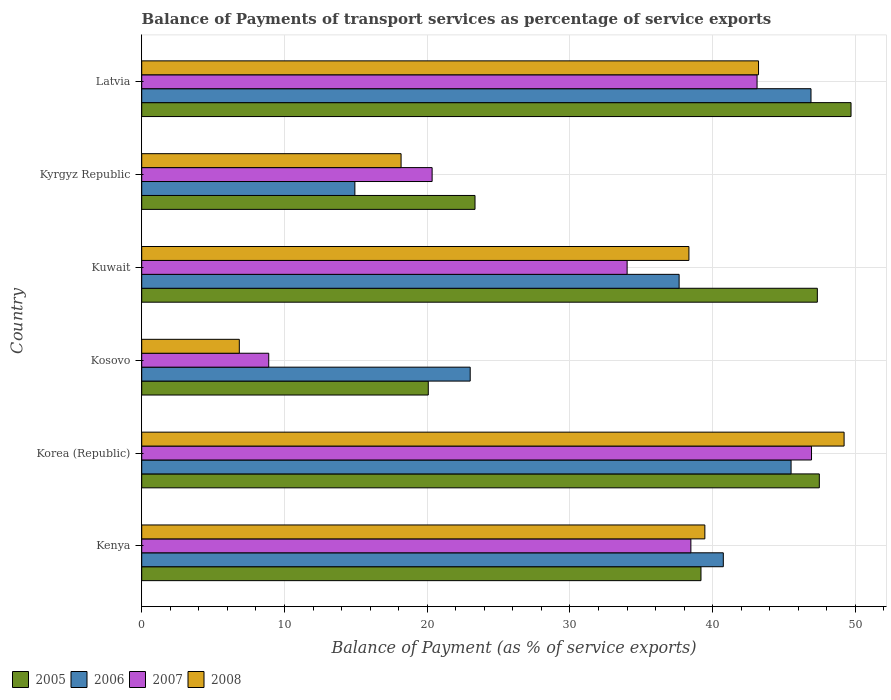How many groups of bars are there?
Make the answer very short. 6. Are the number of bars per tick equal to the number of legend labels?
Make the answer very short. Yes. Are the number of bars on each tick of the Y-axis equal?
Your answer should be compact. Yes. What is the label of the 4th group of bars from the top?
Ensure brevity in your answer.  Kosovo. In how many cases, is the number of bars for a given country not equal to the number of legend labels?
Provide a succinct answer. 0. What is the balance of payments of transport services in 2005 in Korea (Republic)?
Ensure brevity in your answer.  47.47. Across all countries, what is the maximum balance of payments of transport services in 2005?
Ensure brevity in your answer.  49.69. Across all countries, what is the minimum balance of payments of transport services in 2005?
Offer a very short reply. 20.08. In which country was the balance of payments of transport services in 2005 minimum?
Offer a very short reply. Kosovo. What is the total balance of payments of transport services in 2005 in the graph?
Ensure brevity in your answer.  227.1. What is the difference between the balance of payments of transport services in 2005 in Korea (Republic) and that in Latvia?
Provide a succinct answer. -2.22. What is the difference between the balance of payments of transport services in 2008 in Kosovo and the balance of payments of transport services in 2007 in Kyrgyz Republic?
Provide a succinct answer. -13.51. What is the average balance of payments of transport services in 2006 per country?
Give a very brief answer. 34.79. What is the difference between the balance of payments of transport services in 2006 and balance of payments of transport services in 2005 in Kenya?
Keep it short and to the point. 1.56. In how many countries, is the balance of payments of transport services in 2008 greater than 10 %?
Offer a very short reply. 5. What is the ratio of the balance of payments of transport services in 2006 in Kyrgyz Republic to that in Latvia?
Ensure brevity in your answer.  0.32. Is the difference between the balance of payments of transport services in 2006 in Kuwait and Kyrgyz Republic greater than the difference between the balance of payments of transport services in 2005 in Kuwait and Kyrgyz Republic?
Your answer should be compact. No. What is the difference between the highest and the second highest balance of payments of transport services in 2006?
Your response must be concise. 1.4. What is the difference between the highest and the lowest balance of payments of transport services in 2007?
Make the answer very short. 38.03. Is the sum of the balance of payments of transport services in 2006 in Kosovo and Kyrgyz Republic greater than the maximum balance of payments of transport services in 2005 across all countries?
Your answer should be very brief. No. What does the 1st bar from the bottom in Korea (Republic) represents?
Provide a short and direct response. 2005. Is it the case that in every country, the sum of the balance of payments of transport services in 2007 and balance of payments of transport services in 2005 is greater than the balance of payments of transport services in 2008?
Provide a succinct answer. Yes. How many bars are there?
Make the answer very short. 24. Are all the bars in the graph horizontal?
Your answer should be compact. Yes. Are the values on the major ticks of X-axis written in scientific E-notation?
Your answer should be compact. No. How are the legend labels stacked?
Offer a very short reply. Horizontal. What is the title of the graph?
Offer a very short reply. Balance of Payments of transport services as percentage of service exports. Does "1960" appear as one of the legend labels in the graph?
Keep it short and to the point. No. What is the label or title of the X-axis?
Offer a very short reply. Balance of Payment (as % of service exports). What is the Balance of Payment (as % of service exports) in 2005 in Kenya?
Provide a short and direct response. 39.18. What is the Balance of Payment (as % of service exports) of 2006 in Kenya?
Provide a short and direct response. 40.74. What is the Balance of Payment (as % of service exports) in 2007 in Kenya?
Provide a short and direct response. 38.47. What is the Balance of Payment (as % of service exports) of 2008 in Kenya?
Your answer should be very brief. 39.45. What is the Balance of Payment (as % of service exports) of 2005 in Korea (Republic)?
Keep it short and to the point. 47.47. What is the Balance of Payment (as % of service exports) in 2006 in Korea (Republic)?
Ensure brevity in your answer.  45.49. What is the Balance of Payment (as % of service exports) in 2007 in Korea (Republic)?
Provide a succinct answer. 46.92. What is the Balance of Payment (as % of service exports) in 2008 in Korea (Republic)?
Your response must be concise. 49.21. What is the Balance of Payment (as % of service exports) of 2005 in Kosovo?
Make the answer very short. 20.08. What is the Balance of Payment (as % of service exports) in 2006 in Kosovo?
Give a very brief answer. 23.01. What is the Balance of Payment (as % of service exports) in 2007 in Kosovo?
Offer a very short reply. 8.9. What is the Balance of Payment (as % of service exports) in 2008 in Kosovo?
Provide a succinct answer. 6.84. What is the Balance of Payment (as % of service exports) in 2005 in Kuwait?
Offer a very short reply. 47.33. What is the Balance of Payment (as % of service exports) in 2006 in Kuwait?
Your response must be concise. 37.65. What is the Balance of Payment (as % of service exports) of 2007 in Kuwait?
Your response must be concise. 34.01. What is the Balance of Payment (as % of service exports) of 2008 in Kuwait?
Provide a short and direct response. 38.33. What is the Balance of Payment (as % of service exports) in 2005 in Kyrgyz Republic?
Your answer should be compact. 23.35. What is the Balance of Payment (as % of service exports) of 2006 in Kyrgyz Republic?
Offer a very short reply. 14.93. What is the Balance of Payment (as % of service exports) of 2007 in Kyrgyz Republic?
Your response must be concise. 20.34. What is the Balance of Payment (as % of service exports) in 2008 in Kyrgyz Republic?
Offer a very short reply. 18.17. What is the Balance of Payment (as % of service exports) of 2005 in Latvia?
Your response must be concise. 49.69. What is the Balance of Payment (as % of service exports) of 2006 in Latvia?
Provide a succinct answer. 46.89. What is the Balance of Payment (as % of service exports) in 2007 in Latvia?
Offer a very short reply. 43.11. What is the Balance of Payment (as % of service exports) in 2008 in Latvia?
Your answer should be compact. 43.21. Across all countries, what is the maximum Balance of Payment (as % of service exports) of 2005?
Keep it short and to the point. 49.69. Across all countries, what is the maximum Balance of Payment (as % of service exports) of 2006?
Make the answer very short. 46.89. Across all countries, what is the maximum Balance of Payment (as % of service exports) of 2007?
Your answer should be compact. 46.92. Across all countries, what is the maximum Balance of Payment (as % of service exports) of 2008?
Your answer should be compact. 49.21. Across all countries, what is the minimum Balance of Payment (as % of service exports) in 2005?
Your answer should be compact. 20.08. Across all countries, what is the minimum Balance of Payment (as % of service exports) of 2006?
Your answer should be very brief. 14.93. Across all countries, what is the minimum Balance of Payment (as % of service exports) of 2007?
Give a very brief answer. 8.9. Across all countries, what is the minimum Balance of Payment (as % of service exports) of 2008?
Give a very brief answer. 6.84. What is the total Balance of Payment (as % of service exports) in 2005 in the graph?
Offer a very short reply. 227.1. What is the total Balance of Payment (as % of service exports) of 2006 in the graph?
Offer a terse response. 208.72. What is the total Balance of Payment (as % of service exports) of 2007 in the graph?
Ensure brevity in your answer.  191.75. What is the total Balance of Payment (as % of service exports) in 2008 in the graph?
Offer a terse response. 195.21. What is the difference between the Balance of Payment (as % of service exports) in 2005 in Kenya and that in Korea (Republic)?
Your response must be concise. -8.29. What is the difference between the Balance of Payment (as % of service exports) in 2006 in Kenya and that in Korea (Republic)?
Provide a short and direct response. -4.75. What is the difference between the Balance of Payment (as % of service exports) in 2007 in Kenya and that in Korea (Republic)?
Provide a short and direct response. -8.45. What is the difference between the Balance of Payment (as % of service exports) in 2008 in Kenya and that in Korea (Republic)?
Ensure brevity in your answer.  -9.75. What is the difference between the Balance of Payment (as % of service exports) in 2005 in Kenya and that in Kosovo?
Offer a very short reply. 19.1. What is the difference between the Balance of Payment (as % of service exports) of 2006 in Kenya and that in Kosovo?
Your answer should be very brief. 17.73. What is the difference between the Balance of Payment (as % of service exports) of 2007 in Kenya and that in Kosovo?
Offer a very short reply. 29.57. What is the difference between the Balance of Payment (as % of service exports) of 2008 in Kenya and that in Kosovo?
Give a very brief answer. 32.62. What is the difference between the Balance of Payment (as % of service exports) of 2005 in Kenya and that in Kuwait?
Give a very brief answer. -8.15. What is the difference between the Balance of Payment (as % of service exports) of 2006 in Kenya and that in Kuwait?
Your response must be concise. 3.1. What is the difference between the Balance of Payment (as % of service exports) in 2007 in Kenya and that in Kuwait?
Offer a terse response. 4.47. What is the difference between the Balance of Payment (as % of service exports) of 2008 in Kenya and that in Kuwait?
Keep it short and to the point. 1.12. What is the difference between the Balance of Payment (as % of service exports) of 2005 in Kenya and that in Kyrgyz Republic?
Ensure brevity in your answer.  15.83. What is the difference between the Balance of Payment (as % of service exports) in 2006 in Kenya and that in Kyrgyz Republic?
Ensure brevity in your answer.  25.81. What is the difference between the Balance of Payment (as % of service exports) in 2007 in Kenya and that in Kyrgyz Republic?
Provide a succinct answer. 18.13. What is the difference between the Balance of Payment (as % of service exports) of 2008 in Kenya and that in Kyrgyz Republic?
Provide a succinct answer. 21.28. What is the difference between the Balance of Payment (as % of service exports) in 2005 in Kenya and that in Latvia?
Ensure brevity in your answer.  -10.51. What is the difference between the Balance of Payment (as % of service exports) in 2006 in Kenya and that in Latvia?
Ensure brevity in your answer.  -6.14. What is the difference between the Balance of Payment (as % of service exports) in 2007 in Kenya and that in Latvia?
Your answer should be compact. -4.64. What is the difference between the Balance of Payment (as % of service exports) in 2008 in Kenya and that in Latvia?
Your answer should be very brief. -3.76. What is the difference between the Balance of Payment (as % of service exports) in 2005 in Korea (Republic) and that in Kosovo?
Your response must be concise. 27.4. What is the difference between the Balance of Payment (as % of service exports) in 2006 in Korea (Republic) and that in Kosovo?
Provide a succinct answer. 22.48. What is the difference between the Balance of Payment (as % of service exports) of 2007 in Korea (Republic) and that in Kosovo?
Provide a succinct answer. 38.03. What is the difference between the Balance of Payment (as % of service exports) of 2008 in Korea (Republic) and that in Kosovo?
Offer a very short reply. 42.37. What is the difference between the Balance of Payment (as % of service exports) in 2005 in Korea (Republic) and that in Kuwait?
Ensure brevity in your answer.  0.14. What is the difference between the Balance of Payment (as % of service exports) of 2006 in Korea (Republic) and that in Kuwait?
Your answer should be very brief. 7.84. What is the difference between the Balance of Payment (as % of service exports) of 2007 in Korea (Republic) and that in Kuwait?
Give a very brief answer. 12.92. What is the difference between the Balance of Payment (as % of service exports) of 2008 in Korea (Republic) and that in Kuwait?
Ensure brevity in your answer.  10.87. What is the difference between the Balance of Payment (as % of service exports) in 2005 in Korea (Republic) and that in Kyrgyz Republic?
Your response must be concise. 24.12. What is the difference between the Balance of Payment (as % of service exports) in 2006 in Korea (Republic) and that in Kyrgyz Republic?
Keep it short and to the point. 30.56. What is the difference between the Balance of Payment (as % of service exports) in 2007 in Korea (Republic) and that in Kyrgyz Republic?
Your answer should be very brief. 26.58. What is the difference between the Balance of Payment (as % of service exports) in 2008 in Korea (Republic) and that in Kyrgyz Republic?
Your answer should be compact. 31.04. What is the difference between the Balance of Payment (as % of service exports) in 2005 in Korea (Republic) and that in Latvia?
Keep it short and to the point. -2.22. What is the difference between the Balance of Payment (as % of service exports) of 2006 in Korea (Republic) and that in Latvia?
Offer a very short reply. -1.4. What is the difference between the Balance of Payment (as % of service exports) of 2007 in Korea (Republic) and that in Latvia?
Give a very brief answer. 3.82. What is the difference between the Balance of Payment (as % of service exports) of 2008 in Korea (Republic) and that in Latvia?
Keep it short and to the point. 5.99. What is the difference between the Balance of Payment (as % of service exports) of 2005 in Kosovo and that in Kuwait?
Offer a terse response. -27.26. What is the difference between the Balance of Payment (as % of service exports) in 2006 in Kosovo and that in Kuwait?
Keep it short and to the point. -14.64. What is the difference between the Balance of Payment (as % of service exports) of 2007 in Kosovo and that in Kuwait?
Keep it short and to the point. -25.11. What is the difference between the Balance of Payment (as % of service exports) in 2008 in Kosovo and that in Kuwait?
Ensure brevity in your answer.  -31.5. What is the difference between the Balance of Payment (as % of service exports) of 2005 in Kosovo and that in Kyrgyz Republic?
Give a very brief answer. -3.27. What is the difference between the Balance of Payment (as % of service exports) in 2006 in Kosovo and that in Kyrgyz Republic?
Provide a short and direct response. 8.08. What is the difference between the Balance of Payment (as % of service exports) of 2007 in Kosovo and that in Kyrgyz Republic?
Offer a terse response. -11.45. What is the difference between the Balance of Payment (as % of service exports) of 2008 in Kosovo and that in Kyrgyz Republic?
Your answer should be very brief. -11.33. What is the difference between the Balance of Payment (as % of service exports) of 2005 in Kosovo and that in Latvia?
Make the answer very short. -29.62. What is the difference between the Balance of Payment (as % of service exports) of 2006 in Kosovo and that in Latvia?
Your answer should be very brief. -23.87. What is the difference between the Balance of Payment (as % of service exports) of 2007 in Kosovo and that in Latvia?
Keep it short and to the point. -34.21. What is the difference between the Balance of Payment (as % of service exports) of 2008 in Kosovo and that in Latvia?
Provide a succinct answer. -36.38. What is the difference between the Balance of Payment (as % of service exports) of 2005 in Kuwait and that in Kyrgyz Republic?
Offer a terse response. 23.98. What is the difference between the Balance of Payment (as % of service exports) in 2006 in Kuwait and that in Kyrgyz Republic?
Keep it short and to the point. 22.72. What is the difference between the Balance of Payment (as % of service exports) of 2007 in Kuwait and that in Kyrgyz Republic?
Your response must be concise. 13.66. What is the difference between the Balance of Payment (as % of service exports) of 2008 in Kuwait and that in Kyrgyz Republic?
Provide a short and direct response. 20.17. What is the difference between the Balance of Payment (as % of service exports) of 2005 in Kuwait and that in Latvia?
Offer a terse response. -2.36. What is the difference between the Balance of Payment (as % of service exports) of 2006 in Kuwait and that in Latvia?
Keep it short and to the point. -9.24. What is the difference between the Balance of Payment (as % of service exports) of 2007 in Kuwait and that in Latvia?
Your response must be concise. -9.1. What is the difference between the Balance of Payment (as % of service exports) of 2008 in Kuwait and that in Latvia?
Your answer should be compact. -4.88. What is the difference between the Balance of Payment (as % of service exports) of 2005 in Kyrgyz Republic and that in Latvia?
Provide a succinct answer. -26.34. What is the difference between the Balance of Payment (as % of service exports) of 2006 in Kyrgyz Republic and that in Latvia?
Keep it short and to the point. -31.95. What is the difference between the Balance of Payment (as % of service exports) of 2007 in Kyrgyz Republic and that in Latvia?
Your answer should be very brief. -22.76. What is the difference between the Balance of Payment (as % of service exports) of 2008 in Kyrgyz Republic and that in Latvia?
Make the answer very short. -25.04. What is the difference between the Balance of Payment (as % of service exports) in 2005 in Kenya and the Balance of Payment (as % of service exports) in 2006 in Korea (Republic)?
Your answer should be compact. -6.31. What is the difference between the Balance of Payment (as % of service exports) of 2005 in Kenya and the Balance of Payment (as % of service exports) of 2007 in Korea (Republic)?
Your response must be concise. -7.74. What is the difference between the Balance of Payment (as % of service exports) of 2005 in Kenya and the Balance of Payment (as % of service exports) of 2008 in Korea (Republic)?
Keep it short and to the point. -10.03. What is the difference between the Balance of Payment (as % of service exports) in 2006 in Kenya and the Balance of Payment (as % of service exports) in 2007 in Korea (Republic)?
Your answer should be compact. -6.18. What is the difference between the Balance of Payment (as % of service exports) of 2006 in Kenya and the Balance of Payment (as % of service exports) of 2008 in Korea (Republic)?
Your answer should be very brief. -8.46. What is the difference between the Balance of Payment (as % of service exports) of 2007 in Kenya and the Balance of Payment (as % of service exports) of 2008 in Korea (Republic)?
Your response must be concise. -10.73. What is the difference between the Balance of Payment (as % of service exports) of 2005 in Kenya and the Balance of Payment (as % of service exports) of 2006 in Kosovo?
Ensure brevity in your answer.  16.17. What is the difference between the Balance of Payment (as % of service exports) in 2005 in Kenya and the Balance of Payment (as % of service exports) in 2007 in Kosovo?
Provide a short and direct response. 30.28. What is the difference between the Balance of Payment (as % of service exports) in 2005 in Kenya and the Balance of Payment (as % of service exports) in 2008 in Kosovo?
Offer a very short reply. 32.34. What is the difference between the Balance of Payment (as % of service exports) in 2006 in Kenya and the Balance of Payment (as % of service exports) in 2007 in Kosovo?
Your answer should be compact. 31.85. What is the difference between the Balance of Payment (as % of service exports) in 2006 in Kenya and the Balance of Payment (as % of service exports) in 2008 in Kosovo?
Your response must be concise. 33.91. What is the difference between the Balance of Payment (as % of service exports) in 2007 in Kenya and the Balance of Payment (as % of service exports) in 2008 in Kosovo?
Give a very brief answer. 31.63. What is the difference between the Balance of Payment (as % of service exports) of 2005 in Kenya and the Balance of Payment (as % of service exports) of 2006 in Kuwait?
Your answer should be compact. 1.53. What is the difference between the Balance of Payment (as % of service exports) in 2005 in Kenya and the Balance of Payment (as % of service exports) in 2007 in Kuwait?
Your response must be concise. 5.17. What is the difference between the Balance of Payment (as % of service exports) in 2005 in Kenya and the Balance of Payment (as % of service exports) in 2008 in Kuwait?
Provide a short and direct response. 0.84. What is the difference between the Balance of Payment (as % of service exports) of 2006 in Kenya and the Balance of Payment (as % of service exports) of 2007 in Kuwait?
Offer a very short reply. 6.74. What is the difference between the Balance of Payment (as % of service exports) in 2006 in Kenya and the Balance of Payment (as % of service exports) in 2008 in Kuwait?
Keep it short and to the point. 2.41. What is the difference between the Balance of Payment (as % of service exports) of 2007 in Kenya and the Balance of Payment (as % of service exports) of 2008 in Kuwait?
Your answer should be very brief. 0.14. What is the difference between the Balance of Payment (as % of service exports) of 2005 in Kenya and the Balance of Payment (as % of service exports) of 2006 in Kyrgyz Republic?
Provide a succinct answer. 24.25. What is the difference between the Balance of Payment (as % of service exports) of 2005 in Kenya and the Balance of Payment (as % of service exports) of 2007 in Kyrgyz Republic?
Give a very brief answer. 18.84. What is the difference between the Balance of Payment (as % of service exports) in 2005 in Kenya and the Balance of Payment (as % of service exports) in 2008 in Kyrgyz Republic?
Offer a terse response. 21.01. What is the difference between the Balance of Payment (as % of service exports) of 2006 in Kenya and the Balance of Payment (as % of service exports) of 2007 in Kyrgyz Republic?
Make the answer very short. 20.4. What is the difference between the Balance of Payment (as % of service exports) in 2006 in Kenya and the Balance of Payment (as % of service exports) in 2008 in Kyrgyz Republic?
Provide a succinct answer. 22.58. What is the difference between the Balance of Payment (as % of service exports) in 2007 in Kenya and the Balance of Payment (as % of service exports) in 2008 in Kyrgyz Republic?
Your answer should be very brief. 20.3. What is the difference between the Balance of Payment (as % of service exports) in 2005 in Kenya and the Balance of Payment (as % of service exports) in 2006 in Latvia?
Your answer should be compact. -7.71. What is the difference between the Balance of Payment (as % of service exports) of 2005 in Kenya and the Balance of Payment (as % of service exports) of 2007 in Latvia?
Offer a terse response. -3.93. What is the difference between the Balance of Payment (as % of service exports) of 2005 in Kenya and the Balance of Payment (as % of service exports) of 2008 in Latvia?
Your answer should be very brief. -4.03. What is the difference between the Balance of Payment (as % of service exports) of 2006 in Kenya and the Balance of Payment (as % of service exports) of 2007 in Latvia?
Provide a short and direct response. -2.36. What is the difference between the Balance of Payment (as % of service exports) of 2006 in Kenya and the Balance of Payment (as % of service exports) of 2008 in Latvia?
Offer a very short reply. -2.47. What is the difference between the Balance of Payment (as % of service exports) in 2007 in Kenya and the Balance of Payment (as % of service exports) in 2008 in Latvia?
Provide a short and direct response. -4.74. What is the difference between the Balance of Payment (as % of service exports) of 2005 in Korea (Republic) and the Balance of Payment (as % of service exports) of 2006 in Kosovo?
Provide a succinct answer. 24.46. What is the difference between the Balance of Payment (as % of service exports) in 2005 in Korea (Republic) and the Balance of Payment (as % of service exports) in 2007 in Kosovo?
Your answer should be compact. 38.57. What is the difference between the Balance of Payment (as % of service exports) in 2005 in Korea (Republic) and the Balance of Payment (as % of service exports) in 2008 in Kosovo?
Your answer should be compact. 40.63. What is the difference between the Balance of Payment (as % of service exports) of 2006 in Korea (Republic) and the Balance of Payment (as % of service exports) of 2007 in Kosovo?
Offer a terse response. 36.59. What is the difference between the Balance of Payment (as % of service exports) of 2006 in Korea (Republic) and the Balance of Payment (as % of service exports) of 2008 in Kosovo?
Your response must be concise. 38.65. What is the difference between the Balance of Payment (as % of service exports) in 2007 in Korea (Republic) and the Balance of Payment (as % of service exports) in 2008 in Kosovo?
Ensure brevity in your answer.  40.09. What is the difference between the Balance of Payment (as % of service exports) in 2005 in Korea (Republic) and the Balance of Payment (as % of service exports) in 2006 in Kuwait?
Offer a terse response. 9.82. What is the difference between the Balance of Payment (as % of service exports) in 2005 in Korea (Republic) and the Balance of Payment (as % of service exports) in 2007 in Kuwait?
Ensure brevity in your answer.  13.47. What is the difference between the Balance of Payment (as % of service exports) in 2005 in Korea (Republic) and the Balance of Payment (as % of service exports) in 2008 in Kuwait?
Keep it short and to the point. 9.14. What is the difference between the Balance of Payment (as % of service exports) in 2006 in Korea (Republic) and the Balance of Payment (as % of service exports) in 2007 in Kuwait?
Your answer should be compact. 11.49. What is the difference between the Balance of Payment (as % of service exports) of 2006 in Korea (Republic) and the Balance of Payment (as % of service exports) of 2008 in Kuwait?
Provide a succinct answer. 7.16. What is the difference between the Balance of Payment (as % of service exports) in 2007 in Korea (Republic) and the Balance of Payment (as % of service exports) in 2008 in Kuwait?
Provide a succinct answer. 8.59. What is the difference between the Balance of Payment (as % of service exports) in 2005 in Korea (Republic) and the Balance of Payment (as % of service exports) in 2006 in Kyrgyz Republic?
Ensure brevity in your answer.  32.54. What is the difference between the Balance of Payment (as % of service exports) in 2005 in Korea (Republic) and the Balance of Payment (as % of service exports) in 2007 in Kyrgyz Republic?
Make the answer very short. 27.13. What is the difference between the Balance of Payment (as % of service exports) in 2005 in Korea (Republic) and the Balance of Payment (as % of service exports) in 2008 in Kyrgyz Republic?
Your response must be concise. 29.3. What is the difference between the Balance of Payment (as % of service exports) in 2006 in Korea (Republic) and the Balance of Payment (as % of service exports) in 2007 in Kyrgyz Republic?
Your response must be concise. 25.15. What is the difference between the Balance of Payment (as % of service exports) of 2006 in Korea (Republic) and the Balance of Payment (as % of service exports) of 2008 in Kyrgyz Republic?
Your answer should be compact. 27.32. What is the difference between the Balance of Payment (as % of service exports) in 2007 in Korea (Republic) and the Balance of Payment (as % of service exports) in 2008 in Kyrgyz Republic?
Your answer should be very brief. 28.75. What is the difference between the Balance of Payment (as % of service exports) in 2005 in Korea (Republic) and the Balance of Payment (as % of service exports) in 2006 in Latvia?
Offer a terse response. 0.58. What is the difference between the Balance of Payment (as % of service exports) of 2005 in Korea (Republic) and the Balance of Payment (as % of service exports) of 2007 in Latvia?
Offer a very short reply. 4.36. What is the difference between the Balance of Payment (as % of service exports) of 2005 in Korea (Republic) and the Balance of Payment (as % of service exports) of 2008 in Latvia?
Your answer should be very brief. 4.26. What is the difference between the Balance of Payment (as % of service exports) in 2006 in Korea (Republic) and the Balance of Payment (as % of service exports) in 2007 in Latvia?
Make the answer very short. 2.38. What is the difference between the Balance of Payment (as % of service exports) of 2006 in Korea (Republic) and the Balance of Payment (as % of service exports) of 2008 in Latvia?
Make the answer very short. 2.28. What is the difference between the Balance of Payment (as % of service exports) of 2007 in Korea (Republic) and the Balance of Payment (as % of service exports) of 2008 in Latvia?
Make the answer very short. 3.71. What is the difference between the Balance of Payment (as % of service exports) in 2005 in Kosovo and the Balance of Payment (as % of service exports) in 2006 in Kuwait?
Your answer should be very brief. -17.57. What is the difference between the Balance of Payment (as % of service exports) of 2005 in Kosovo and the Balance of Payment (as % of service exports) of 2007 in Kuwait?
Make the answer very short. -13.93. What is the difference between the Balance of Payment (as % of service exports) of 2005 in Kosovo and the Balance of Payment (as % of service exports) of 2008 in Kuwait?
Give a very brief answer. -18.26. What is the difference between the Balance of Payment (as % of service exports) of 2006 in Kosovo and the Balance of Payment (as % of service exports) of 2007 in Kuwait?
Offer a very short reply. -10.99. What is the difference between the Balance of Payment (as % of service exports) of 2006 in Kosovo and the Balance of Payment (as % of service exports) of 2008 in Kuwait?
Your answer should be compact. -15.32. What is the difference between the Balance of Payment (as % of service exports) of 2007 in Kosovo and the Balance of Payment (as % of service exports) of 2008 in Kuwait?
Provide a short and direct response. -29.44. What is the difference between the Balance of Payment (as % of service exports) in 2005 in Kosovo and the Balance of Payment (as % of service exports) in 2006 in Kyrgyz Republic?
Ensure brevity in your answer.  5.14. What is the difference between the Balance of Payment (as % of service exports) in 2005 in Kosovo and the Balance of Payment (as % of service exports) in 2007 in Kyrgyz Republic?
Offer a very short reply. -0.27. What is the difference between the Balance of Payment (as % of service exports) of 2005 in Kosovo and the Balance of Payment (as % of service exports) of 2008 in Kyrgyz Republic?
Your answer should be compact. 1.91. What is the difference between the Balance of Payment (as % of service exports) in 2006 in Kosovo and the Balance of Payment (as % of service exports) in 2007 in Kyrgyz Republic?
Make the answer very short. 2.67. What is the difference between the Balance of Payment (as % of service exports) in 2006 in Kosovo and the Balance of Payment (as % of service exports) in 2008 in Kyrgyz Republic?
Ensure brevity in your answer.  4.84. What is the difference between the Balance of Payment (as % of service exports) of 2007 in Kosovo and the Balance of Payment (as % of service exports) of 2008 in Kyrgyz Republic?
Your answer should be compact. -9.27. What is the difference between the Balance of Payment (as % of service exports) of 2005 in Kosovo and the Balance of Payment (as % of service exports) of 2006 in Latvia?
Keep it short and to the point. -26.81. What is the difference between the Balance of Payment (as % of service exports) in 2005 in Kosovo and the Balance of Payment (as % of service exports) in 2007 in Latvia?
Offer a terse response. -23.03. What is the difference between the Balance of Payment (as % of service exports) in 2005 in Kosovo and the Balance of Payment (as % of service exports) in 2008 in Latvia?
Keep it short and to the point. -23.14. What is the difference between the Balance of Payment (as % of service exports) of 2006 in Kosovo and the Balance of Payment (as % of service exports) of 2007 in Latvia?
Offer a terse response. -20.1. What is the difference between the Balance of Payment (as % of service exports) in 2006 in Kosovo and the Balance of Payment (as % of service exports) in 2008 in Latvia?
Offer a terse response. -20.2. What is the difference between the Balance of Payment (as % of service exports) in 2007 in Kosovo and the Balance of Payment (as % of service exports) in 2008 in Latvia?
Ensure brevity in your answer.  -34.31. What is the difference between the Balance of Payment (as % of service exports) of 2005 in Kuwait and the Balance of Payment (as % of service exports) of 2006 in Kyrgyz Republic?
Give a very brief answer. 32.4. What is the difference between the Balance of Payment (as % of service exports) of 2005 in Kuwait and the Balance of Payment (as % of service exports) of 2007 in Kyrgyz Republic?
Ensure brevity in your answer.  26.99. What is the difference between the Balance of Payment (as % of service exports) in 2005 in Kuwait and the Balance of Payment (as % of service exports) in 2008 in Kyrgyz Republic?
Provide a succinct answer. 29.16. What is the difference between the Balance of Payment (as % of service exports) in 2006 in Kuwait and the Balance of Payment (as % of service exports) in 2007 in Kyrgyz Republic?
Provide a short and direct response. 17.3. What is the difference between the Balance of Payment (as % of service exports) of 2006 in Kuwait and the Balance of Payment (as % of service exports) of 2008 in Kyrgyz Republic?
Ensure brevity in your answer.  19.48. What is the difference between the Balance of Payment (as % of service exports) of 2007 in Kuwait and the Balance of Payment (as % of service exports) of 2008 in Kyrgyz Republic?
Ensure brevity in your answer.  15.84. What is the difference between the Balance of Payment (as % of service exports) of 2005 in Kuwait and the Balance of Payment (as % of service exports) of 2006 in Latvia?
Your answer should be compact. 0.44. What is the difference between the Balance of Payment (as % of service exports) of 2005 in Kuwait and the Balance of Payment (as % of service exports) of 2007 in Latvia?
Your response must be concise. 4.22. What is the difference between the Balance of Payment (as % of service exports) of 2005 in Kuwait and the Balance of Payment (as % of service exports) of 2008 in Latvia?
Make the answer very short. 4.12. What is the difference between the Balance of Payment (as % of service exports) in 2006 in Kuwait and the Balance of Payment (as % of service exports) in 2007 in Latvia?
Make the answer very short. -5.46. What is the difference between the Balance of Payment (as % of service exports) in 2006 in Kuwait and the Balance of Payment (as % of service exports) in 2008 in Latvia?
Offer a terse response. -5.56. What is the difference between the Balance of Payment (as % of service exports) in 2007 in Kuwait and the Balance of Payment (as % of service exports) in 2008 in Latvia?
Provide a succinct answer. -9.21. What is the difference between the Balance of Payment (as % of service exports) of 2005 in Kyrgyz Republic and the Balance of Payment (as % of service exports) of 2006 in Latvia?
Give a very brief answer. -23.54. What is the difference between the Balance of Payment (as % of service exports) of 2005 in Kyrgyz Republic and the Balance of Payment (as % of service exports) of 2007 in Latvia?
Ensure brevity in your answer.  -19.76. What is the difference between the Balance of Payment (as % of service exports) of 2005 in Kyrgyz Republic and the Balance of Payment (as % of service exports) of 2008 in Latvia?
Keep it short and to the point. -19.86. What is the difference between the Balance of Payment (as % of service exports) in 2006 in Kyrgyz Republic and the Balance of Payment (as % of service exports) in 2007 in Latvia?
Ensure brevity in your answer.  -28.18. What is the difference between the Balance of Payment (as % of service exports) in 2006 in Kyrgyz Republic and the Balance of Payment (as % of service exports) in 2008 in Latvia?
Offer a terse response. -28.28. What is the difference between the Balance of Payment (as % of service exports) of 2007 in Kyrgyz Republic and the Balance of Payment (as % of service exports) of 2008 in Latvia?
Make the answer very short. -22.87. What is the average Balance of Payment (as % of service exports) in 2005 per country?
Ensure brevity in your answer.  37.85. What is the average Balance of Payment (as % of service exports) in 2006 per country?
Make the answer very short. 34.79. What is the average Balance of Payment (as % of service exports) of 2007 per country?
Your answer should be compact. 31.96. What is the average Balance of Payment (as % of service exports) of 2008 per country?
Ensure brevity in your answer.  32.54. What is the difference between the Balance of Payment (as % of service exports) in 2005 and Balance of Payment (as % of service exports) in 2006 in Kenya?
Provide a short and direct response. -1.56. What is the difference between the Balance of Payment (as % of service exports) of 2005 and Balance of Payment (as % of service exports) of 2007 in Kenya?
Offer a terse response. 0.71. What is the difference between the Balance of Payment (as % of service exports) of 2005 and Balance of Payment (as % of service exports) of 2008 in Kenya?
Make the answer very short. -0.27. What is the difference between the Balance of Payment (as % of service exports) in 2006 and Balance of Payment (as % of service exports) in 2007 in Kenya?
Provide a succinct answer. 2.27. What is the difference between the Balance of Payment (as % of service exports) in 2006 and Balance of Payment (as % of service exports) in 2008 in Kenya?
Ensure brevity in your answer.  1.29. What is the difference between the Balance of Payment (as % of service exports) of 2007 and Balance of Payment (as % of service exports) of 2008 in Kenya?
Provide a short and direct response. -0.98. What is the difference between the Balance of Payment (as % of service exports) of 2005 and Balance of Payment (as % of service exports) of 2006 in Korea (Republic)?
Provide a succinct answer. 1.98. What is the difference between the Balance of Payment (as % of service exports) of 2005 and Balance of Payment (as % of service exports) of 2007 in Korea (Republic)?
Ensure brevity in your answer.  0.55. What is the difference between the Balance of Payment (as % of service exports) in 2005 and Balance of Payment (as % of service exports) in 2008 in Korea (Republic)?
Your answer should be compact. -1.74. What is the difference between the Balance of Payment (as % of service exports) in 2006 and Balance of Payment (as % of service exports) in 2007 in Korea (Republic)?
Offer a terse response. -1.43. What is the difference between the Balance of Payment (as % of service exports) in 2006 and Balance of Payment (as % of service exports) in 2008 in Korea (Republic)?
Provide a short and direct response. -3.71. What is the difference between the Balance of Payment (as % of service exports) of 2007 and Balance of Payment (as % of service exports) of 2008 in Korea (Republic)?
Offer a terse response. -2.28. What is the difference between the Balance of Payment (as % of service exports) in 2005 and Balance of Payment (as % of service exports) in 2006 in Kosovo?
Your answer should be very brief. -2.94. What is the difference between the Balance of Payment (as % of service exports) of 2005 and Balance of Payment (as % of service exports) of 2007 in Kosovo?
Offer a very short reply. 11.18. What is the difference between the Balance of Payment (as % of service exports) of 2005 and Balance of Payment (as % of service exports) of 2008 in Kosovo?
Give a very brief answer. 13.24. What is the difference between the Balance of Payment (as % of service exports) of 2006 and Balance of Payment (as % of service exports) of 2007 in Kosovo?
Keep it short and to the point. 14.11. What is the difference between the Balance of Payment (as % of service exports) in 2006 and Balance of Payment (as % of service exports) in 2008 in Kosovo?
Keep it short and to the point. 16.18. What is the difference between the Balance of Payment (as % of service exports) of 2007 and Balance of Payment (as % of service exports) of 2008 in Kosovo?
Give a very brief answer. 2.06. What is the difference between the Balance of Payment (as % of service exports) in 2005 and Balance of Payment (as % of service exports) in 2006 in Kuwait?
Give a very brief answer. 9.68. What is the difference between the Balance of Payment (as % of service exports) in 2005 and Balance of Payment (as % of service exports) in 2007 in Kuwait?
Make the answer very short. 13.33. What is the difference between the Balance of Payment (as % of service exports) in 2005 and Balance of Payment (as % of service exports) in 2008 in Kuwait?
Provide a succinct answer. 9. What is the difference between the Balance of Payment (as % of service exports) of 2006 and Balance of Payment (as % of service exports) of 2007 in Kuwait?
Provide a short and direct response. 3.64. What is the difference between the Balance of Payment (as % of service exports) in 2006 and Balance of Payment (as % of service exports) in 2008 in Kuwait?
Give a very brief answer. -0.69. What is the difference between the Balance of Payment (as % of service exports) in 2007 and Balance of Payment (as % of service exports) in 2008 in Kuwait?
Provide a succinct answer. -4.33. What is the difference between the Balance of Payment (as % of service exports) of 2005 and Balance of Payment (as % of service exports) of 2006 in Kyrgyz Republic?
Offer a terse response. 8.42. What is the difference between the Balance of Payment (as % of service exports) in 2005 and Balance of Payment (as % of service exports) in 2007 in Kyrgyz Republic?
Offer a terse response. 3. What is the difference between the Balance of Payment (as % of service exports) in 2005 and Balance of Payment (as % of service exports) in 2008 in Kyrgyz Republic?
Offer a terse response. 5.18. What is the difference between the Balance of Payment (as % of service exports) in 2006 and Balance of Payment (as % of service exports) in 2007 in Kyrgyz Republic?
Your answer should be very brief. -5.41. What is the difference between the Balance of Payment (as % of service exports) of 2006 and Balance of Payment (as % of service exports) of 2008 in Kyrgyz Republic?
Your response must be concise. -3.24. What is the difference between the Balance of Payment (as % of service exports) of 2007 and Balance of Payment (as % of service exports) of 2008 in Kyrgyz Republic?
Your answer should be very brief. 2.18. What is the difference between the Balance of Payment (as % of service exports) of 2005 and Balance of Payment (as % of service exports) of 2006 in Latvia?
Offer a terse response. 2.8. What is the difference between the Balance of Payment (as % of service exports) of 2005 and Balance of Payment (as % of service exports) of 2007 in Latvia?
Give a very brief answer. 6.58. What is the difference between the Balance of Payment (as % of service exports) in 2005 and Balance of Payment (as % of service exports) in 2008 in Latvia?
Keep it short and to the point. 6.48. What is the difference between the Balance of Payment (as % of service exports) of 2006 and Balance of Payment (as % of service exports) of 2007 in Latvia?
Your response must be concise. 3.78. What is the difference between the Balance of Payment (as % of service exports) in 2006 and Balance of Payment (as % of service exports) in 2008 in Latvia?
Make the answer very short. 3.67. What is the difference between the Balance of Payment (as % of service exports) in 2007 and Balance of Payment (as % of service exports) in 2008 in Latvia?
Your response must be concise. -0.1. What is the ratio of the Balance of Payment (as % of service exports) in 2005 in Kenya to that in Korea (Republic)?
Keep it short and to the point. 0.83. What is the ratio of the Balance of Payment (as % of service exports) in 2006 in Kenya to that in Korea (Republic)?
Provide a succinct answer. 0.9. What is the ratio of the Balance of Payment (as % of service exports) of 2007 in Kenya to that in Korea (Republic)?
Make the answer very short. 0.82. What is the ratio of the Balance of Payment (as % of service exports) in 2008 in Kenya to that in Korea (Republic)?
Keep it short and to the point. 0.8. What is the ratio of the Balance of Payment (as % of service exports) of 2005 in Kenya to that in Kosovo?
Your answer should be compact. 1.95. What is the ratio of the Balance of Payment (as % of service exports) of 2006 in Kenya to that in Kosovo?
Provide a short and direct response. 1.77. What is the ratio of the Balance of Payment (as % of service exports) of 2007 in Kenya to that in Kosovo?
Offer a very short reply. 4.32. What is the ratio of the Balance of Payment (as % of service exports) in 2008 in Kenya to that in Kosovo?
Your answer should be compact. 5.77. What is the ratio of the Balance of Payment (as % of service exports) in 2005 in Kenya to that in Kuwait?
Your answer should be compact. 0.83. What is the ratio of the Balance of Payment (as % of service exports) in 2006 in Kenya to that in Kuwait?
Ensure brevity in your answer.  1.08. What is the ratio of the Balance of Payment (as % of service exports) in 2007 in Kenya to that in Kuwait?
Ensure brevity in your answer.  1.13. What is the ratio of the Balance of Payment (as % of service exports) in 2008 in Kenya to that in Kuwait?
Offer a terse response. 1.03. What is the ratio of the Balance of Payment (as % of service exports) in 2005 in Kenya to that in Kyrgyz Republic?
Provide a succinct answer. 1.68. What is the ratio of the Balance of Payment (as % of service exports) of 2006 in Kenya to that in Kyrgyz Republic?
Your answer should be very brief. 2.73. What is the ratio of the Balance of Payment (as % of service exports) of 2007 in Kenya to that in Kyrgyz Republic?
Offer a very short reply. 1.89. What is the ratio of the Balance of Payment (as % of service exports) in 2008 in Kenya to that in Kyrgyz Republic?
Your answer should be very brief. 2.17. What is the ratio of the Balance of Payment (as % of service exports) of 2005 in Kenya to that in Latvia?
Give a very brief answer. 0.79. What is the ratio of the Balance of Payment (as % of service exports) in 2006 in Kenya to that in Latvia?
Provide a succinct answer. 0.87. What is the ratio of the Balance of Payment (as % of service exports) in 2007 in Kenya to that in Latvia?
Offer a very short reply. 0.89. What is the ratio of the Balance of Payment (as % of service exports) of 2005 in Korea (Republic) to that in Kosovo?
Give a very brief answer. 2.36. What is the ratio of the Balance of Payment (as % of service exports) of 2006 in Korea (Republic) to that in Kosovo?
Ensure brevity in your answer.  1.98. What is the ratio of the Balance of Payment (as % of service exports) of 2007 in Korea (Republic) to that in Kosovo?
Offer a terse response. 5.27. What is the ratio of the Balance of Payment (as % of service exports) of 2008 in Korea (Republic) to that in Kosovo?
Make the answer very short. 7.2. What is the ratio of the Balance of Payment (as % of service exports) of 2006 in Korea (Republic) to that in Kuwait?
Your answer should be compact. 1.21. What is the ratio of the Balance of Payment (as % of service exports) in 2007 in Korea (Republic) to that in Kuwait?
Provide a short and direct response. 1.38. What is the ratio of the Balance of Payment (as % of service exports) of 2008 in Korea (Republic) to that in Kuwait?
Offer a very short reply. 1.28. What is the ratio of the Balance of Payment (as % of service exports) of 2005 in Korea (Republic) to that in Kyrgyz Republic?
Provide a succinct answer. 2.03. What is the ratio of the Balance of Payment (as % of service exports) in 2006 in Korea (Republic) to that in Kyrgyz Republic?
Give a very brief answer. 3.05. What is the ratio of the Balance of Payment (as % of service exports) of 2007 in Korea (Republic) to that in Kyrgyz Republic?
Provide a succinct answer. 2.31. What is the ratio of the Balance of Payment (as % of service exports) of 2008 in Korea (Republic) to that in Kyrgyz Republic?
Your response must be concise. 2.71. What is the ratio of the Balance of Payment (as % of service exports) in 2005 in Korea (Republic) to that in Latvia?
Provide a succinct answer. 0.96. What is the ratio of the Balance of Payment (as % of service exports) of 2006 in Korea (Republic) to that in Latvia?
Provide a short and direct response. 0.97. What is the ratio of the Balance of Payment (as % of service exports) in 2007 in Korea (Republic) to that in Latvia?
Your answer should be very brief. 1.09. What is the ratio of the Balance of Payment (as % of service exports) of 2008 in Korea (Republic) to that in Latvia?
Your response must be concise. 1.14. What is the ratio of the Balance of Payment (as % of service exports) of 2005 in Kosovo to that in Kuwait?
Provide a succinct answer. 0.42. What is the ratio of the Balance of Payment (as % of service exports) in 2006 in Kosovo to that in Kuwait?
Your answer should be very brief. 0.61. What is the ratio of the Balance of Payment (as % of service exports) of 2007 in Kosovo to that in Kuwait?
Provide a short and direct response. 0.26. What is the ratio of the Balance of Payment (as % of service exports) of 2008 in Kosovo to that in Kuwait?
Make the answer very short. 0.18. What is the ratio of the Balance of Payment (as % of service exports) in 2005 in Kosovo to that in Kyrgyz Republic?
Your answer should be very brief. 0.86. What is the ratio of the Balance of Payment (as % of service exports) in 2006 in Kosovo to that in Kyrgyz Republic?
Keep it short and to the point. 1.54. What is the ratio of the Balance of Payment (as % of service exports) of 2007 in Kosovo to that in Kyrgyz Republic?
Keep it short and to the point. 0.44. What is the ratio of the Balance of Payment (as % of service exports) of 2008 in Kosovo to that in Kyrgyz Republic?
Ensure brevity in your answer.  0.38. What is the ratio of the Balance of Payment (as % of service exports) of 2005 in Kosovo to that in Latvia?
Your answer should be very brief. 0.4. What is the ratio of the Balance of Payment (as % of service exports) in 2006 in Kosovo to that in Latvia?
Your answer should be compact. 0.49. What is the ratio of the Balance of Payment (as % of service exports) of 2007 in Kosovo to that in Latvia?
Provide a succinct answer. 0.21. What is the ratio of the Balance of Payment (as % of service exports) in 2008 in Kosovo to that in Latvia?
Make the answer very short. 0.16. What is the ratio of the Balance of Payment (as % of service exports) in 2005 in Kuwait to that in Kyrgyz Republic?
Give a very brief answer. 2.03. What is the ratio of the Balance of Payment (as % of service exports) in 2006 in Kuwait to that in Kyrgyz Republic?
Provide a succinct answer. 2.52. What is the ratio of the Balance of Payment (as % of service exports) of 2007 in Kuwait to that in Kyrgyz Republic?
Your answer should be compact. 1.67. What is the ratio of the Balance of Payment (as % of service exports) in 2008 in Kuwait to that in Kyrgyz Republic?
Your answer should be very brief. 2.11. What is the ratio of the Balance of Payment (as % of service exports) in 2005 in Kuwait to that in Latvia?
Provide a succinct answer. 0.95. What is the ratio of the Balance of Payment (as % of service exports) in 2006 in Kuwait to that in Latvia?
Offer a terse response. 0.8. What is the ratio of the Balance of Payment (as % of service exports) in 2007 in Kuwait to that in Latvia?
Make the answer very short. 0.79. What is the ratio of the Balance of Payment (as % of service exports) in 2008 in Kuwait to that in Latvia?
Give a very brief answer. 0.89. What is the ratio of the Balance of Payment (as % of service exports) in 2005 in Kyrgyz Republic to that in Latvia?
Make the answer very short. 0.47. What is the ratio of the Balance of Payment (as % of service exports) in 2006 in Kyrgyz Republic to that in Latvia?
Ensure brevity in your answer.  0.32. What is the ratio of the Balance of Payment (as % of service exports) in 2007 in Kyrgyz Republic to that in Latvia?
Ensure brevity in your answer.  0.47. What is the ratio of the Balance of Payment (as % of service exports) in 2008 in Kyrgyz Republic to that in Latvia?
Your answer should be compact. 0.42. What is the difference between the highest and the second highest Balance of Payment (as % of service exports) in 2005?
Give a very brief answer. 2.22. What is the difference between the highest and the second highest Balance of Payment (as % of service exports) in 2006?
Your response must be concise. 1.4. What is the difference between the highest and the second highest Balance of Payment (as % of service exports) of 2007?
Offer a very short reply. 3.82. What is the difference between the highest and the second highest Balance of Payment (as % of service exports) in 2008?
Provide a succinct answer. 5.99. What is the difference between the highest and the lowest Balance of Payment (as % of service exports) in 2005?
Your response must be concise. 29.62. What is the difference between the highest and the lowest Balance of Payment (as % of service exports) of 2006?
Offer a very short reply. 31.95. What is the difference between the highest and the lowest Balance of Payment (as % of service exports) of 2007?
Make the answer very short. 38.03. What is the difference between the highest and the lowest Balance of Payment (as % of service exports) in 2008?
Your answer should be compact. 42.37. 